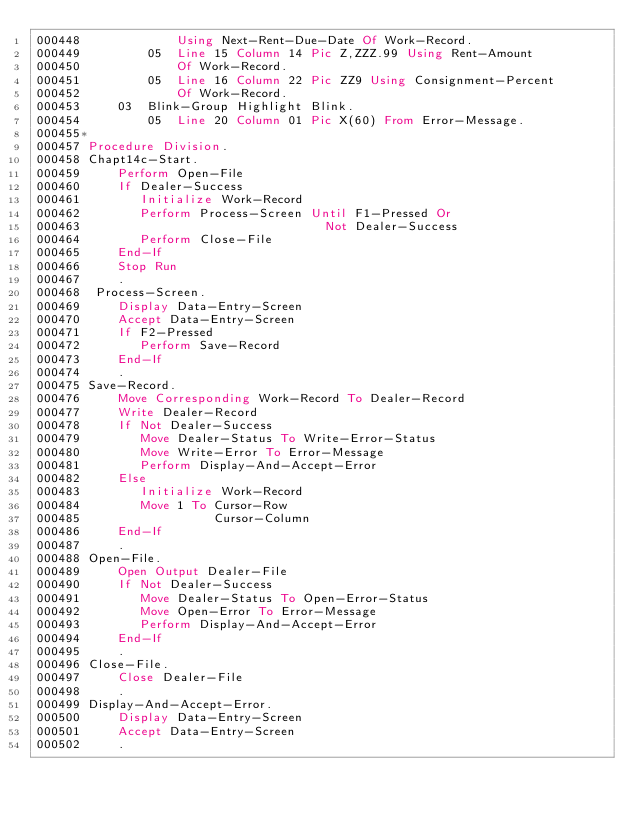Convert code to text. <code><loc_0><loc_0><loc_500><loc_500><_COBOL_>000448             Using Next-Rent-Due-Date Of Work-Record.
000449         05  Line 15 Column 14 Pic Z,ZZZ.99 Using Rent-Amount
000450             Of Work-Record.
000451         05  Line 16 Column 22 Pic ZZ9 Using Consignment-Percent
000452             Of Work-Record.
000453     03  Blink-Group Highlight Blink.
000454         05  Line 20 Column 01 Pic X(60) From Error-Message.
000455*
000457 Procedure Division.
000458 Chapt14c-Start.
000459     Perform Open-File
000460     If Dealer-Success
000461        Initialize Work-Record
000462        Perform Process-Screen Until F1-Pressed Or
000463                                 Not Dealer-Success
000464        Perform Close-File
000465     End-If
000466     Stop Run
000467     .
000468  Process-Screen.
000469     Display Data-Entry-Screen
000470     Accept Data-Entry-Screen
000471     If F2-Pressed
000472        Perform Save-Record
000473     End-If
000474     .
000475 Save-Record.
000476     Move Corresponding Work-Record To Dealer-Record
000477     Write Dealer-Record
000478     If Not Dealer-Success
000479        Move Dealer-Status To Write-Error-Status
000480        Move Write-Error To Error-Message
000481        Perform Display-And-Accept-Error
000482     Else
000483        Initialize Work-Record
000484        Move 1 To Cursor-Row
000485                  Cursor-Column
000486     End-If
000487     .
000488 Open-File.
000489     Open Output Dealer-File
000490     If Not Dealer-Success
000491        Move Dealer-Status To Open-Error-Status
000492        Move Open-Error To Error-Message
000493        Perform Display-And-Accept-Error
000494     End-If
000495     .
000496 Close-File.
000497     Close Dealer-File
000498     .
000499 Display-And-Accept-Error.
000500     Display Data-Entry-Screen
000501     Accept Data-Entry-Screen
000502     .</code> 